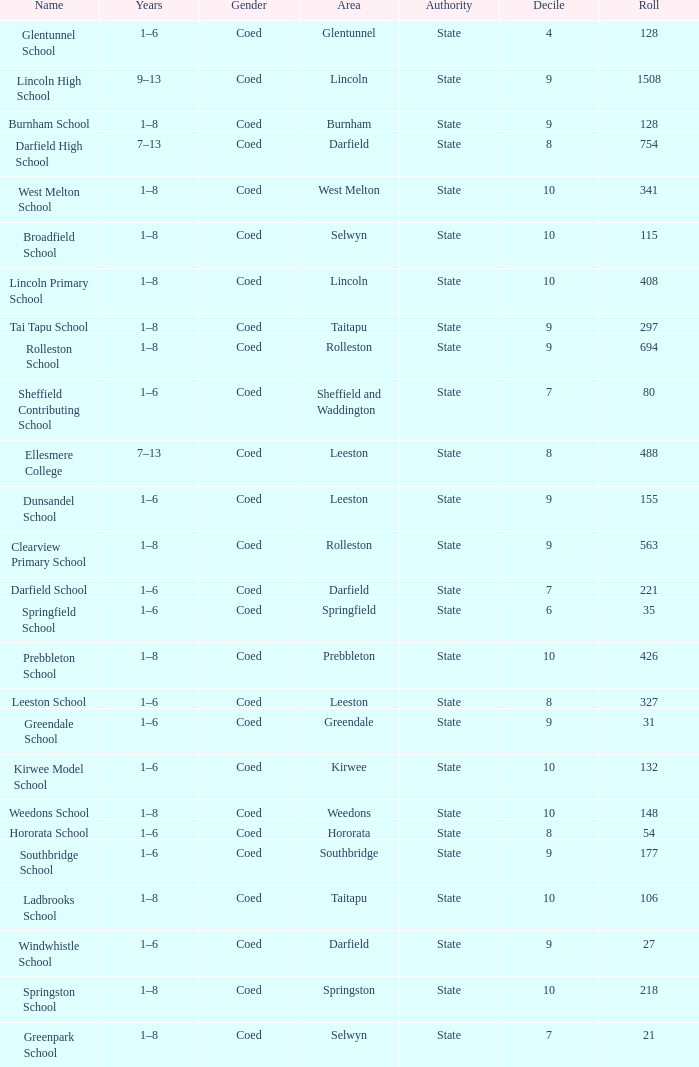Which name has a Roll larger than 297, and Years of 7–13? Darfield High School, Ellesmere College. 